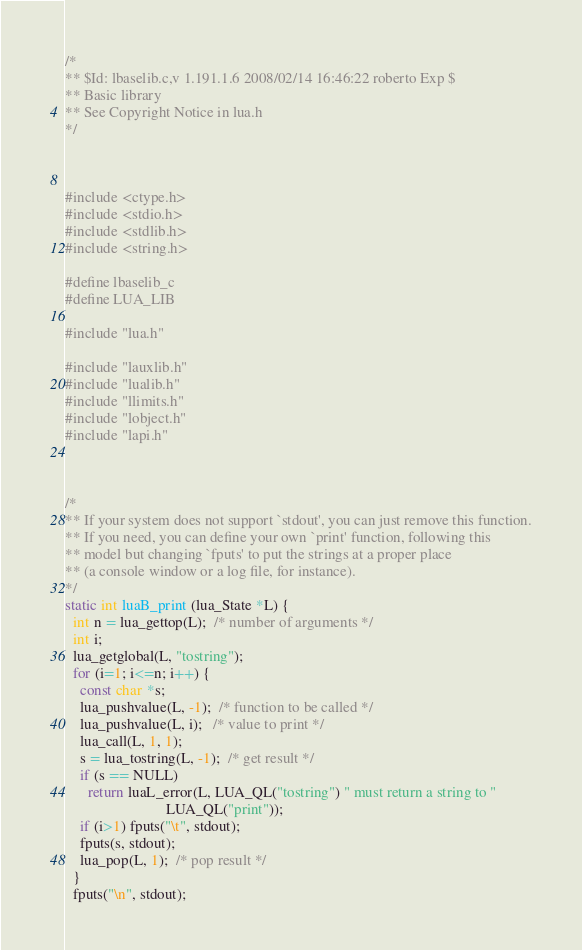Convert code to text. <code><loc_0><loc_0><loc_500><loc_500><_C_>/*
** $Id: lbaselib.c,v 1.191.1.6 2008/02/14 16:46:22 roberto Exp $
** Basic library
** See Copyright Notice in lua.h
*/



#include <ctype.h>
#include <stdio.h>
#include <stdlib.h>
#include <string.h>

#define lbaselib_c
#define LUA_LIB

#include "lua.h"

#include "lauxlib.h"
#include "lualib.h"
#include "llimits.h"
#include "lobject.h"
#include "lapi.h"



/*
** If your system does not support `stdout', you can just remove this function.
** If you need, you can define your own `print' function, following this
** model but changing `fputs' to put the strings at a proper place
** (a console window or a log file, for instance).
*/
static int luaB_print (lua_State *L) {
  int n = lua_gettop(L);  /* number of arguments */
  int i;
  lua_getglobal(L, "tostring");
  for (i=1; i<=n; i++) {
    const char *s;
    lua_pushvalue(L, -1);  /* function to be called */
    lua_pushvalue(L, i);   /* value to print */
    lua_call(L, 1, 1);
    s = lua_tostring(L, -1);  /* get result */
    if (s == NULL)
      return luaL_error(L, LUA_QL("tostring") " must return a string to "
                           LUA_QL("print"));
    if (i>1) fputs("\t", stdout);
    fputs(s, stdout);
    lua_pop(L, 1);  /* pop result */
  }
  fputs("\n", stdout);</code> 